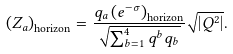Convert formula to latex. <formula><loc_0><loc_0><loc_500><loc_500>\left ( Z _ { a } \right ) _ { \text {horizon} } = \frac { q _ { a } \left ( e ^ { - \sigma } \right ) _ { \text {horizon} } } { \sqrt { \sum _ { b = 1 } ^ { 4 } q ^ { b } q _ { b } } } \sqrt { \left | Q ^ { 2 } \right | } .</formula> 